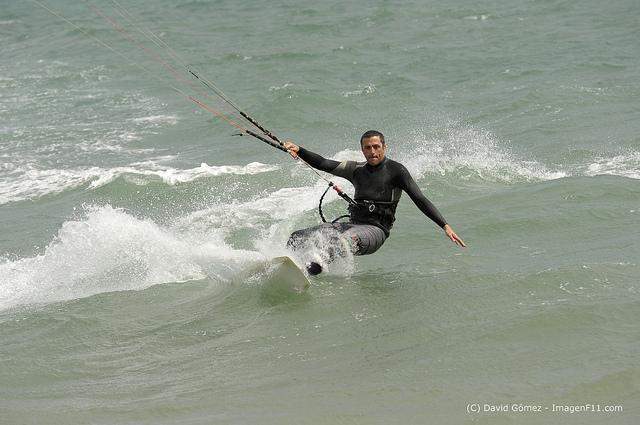Is this person wearing a wetsuit?
Answer briefly. Yes. Is he windsurfing?
Concise answer only. Yes. What sport is this?
Short answer required. Water skiing. Is there water in this picture?
Give a very brief answer. Yes. 